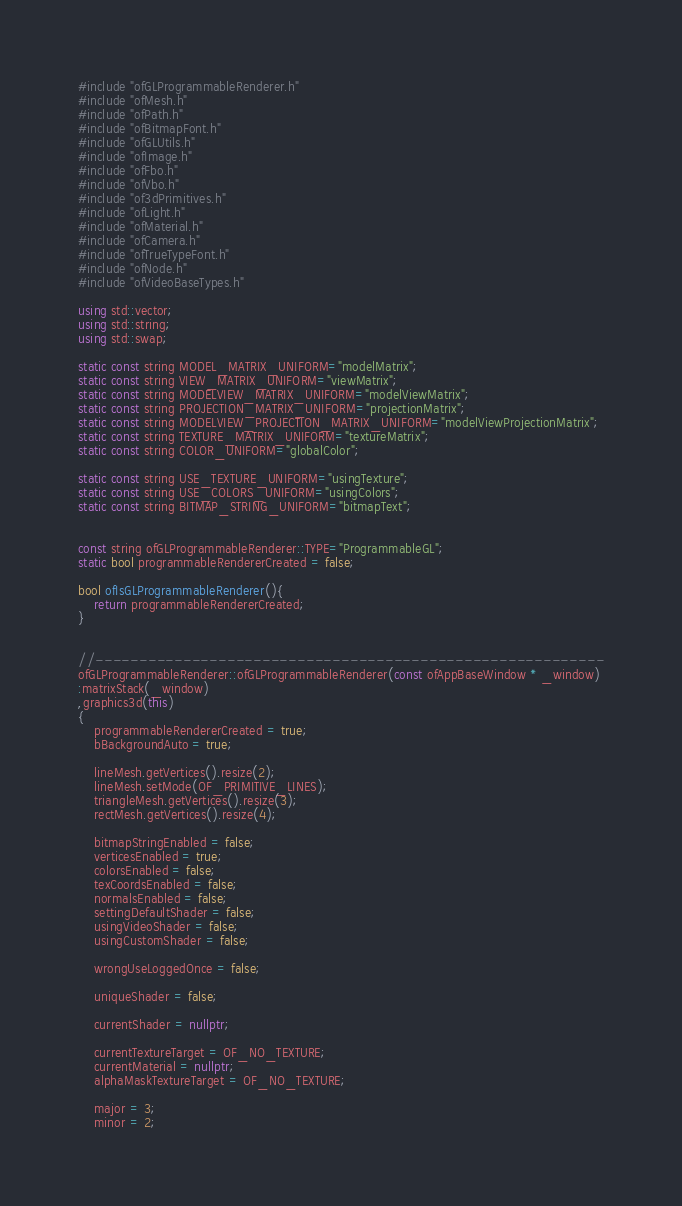<code> <loc_0><loc_0><loc_500><loc_500><_C++_>#include "ofGLProgrammableRenderer.h"
#include "ofMesh.h"
#include "ofPath.h"
#include "ofBitmapFont.h"
#include "ofGLUtils.h"
#include "ofImage.h"
#include "ofFbo.h"
#include "ofVbo.h"
#include "of3dPrimitives.h"
#include "ofLight.h"
#include "ofMaterial.h"
#include "ofCamera.h"
#include "ofTrueTypeFont.h"
#include "ofNode.h"
#include "ofVideoBaseTypes.h"

using std::vector;
using std::string;
using std::swap;

static const string MODEL_MATRIX_UNIFORM="modelMatrix";
static const string VIEW_MATRIX_UNIFORM="viewMatrix";
static const string MODELVIEW_MATRIX_UNIFORM="modelViewMatrix";
static const string PROJECTION_MATRIX_UNIFORM="projectionMatrix";
static const string MODELVIEW_PROJECTION_MATRIX_UNIFORM="modelViewProjectionMatrix";
static const string TEXTURE_MATRIX_UNIFORM="textureMatrix";
static const string COLOR_UNIFORM="globalColor";

static const string USE_TEXTURE_UNIFORM="usingTexture";
static const string USE_COLORS_UNIFORM="usingColors";
static const string BITMAP_STRING_UNIFORM="bitmapText";


const string ofGLProgrammableRenderer::TYPE="ProgrammableGL";
static bool programmableRendererCreated = false;

bool ofIsGLProgrammableRenderer(){
	return programmableRendererCreated;
}


//----------------------------------------------------------
ofGLProgrammableRenderer::ofGLProgrammableRenderer(const ofAppBaseWindow * _window)
:matrixStack(_window)
,graphics3d(this)
{
	programmableRendererCreated = true;
	bBackgroundAuto = true;

	lineMesh.getVertices().resize(2);
	lineMesh.setMode(OF_PRIMITIVE_LINES);
	triangleMesh.getVertices().resize(3);
	rectMesh.getVertices().resize(4);

	bitmapStringEnabled = false;
    verticesEnabled = true;
    colorsEnabled = false;
    texCoordsEnabled = false;
    normalsEnabled = false;
	settingDefaultShader = false;
	usingVideoShader = false;
	usingCustomShader = false;

	wrongUseLoggedOnce = false;

	uniqueShader = false;

	currentShader = nullptr;

	currentTextureTarget = OF_NO_TEXTURE;
	currentMaterial = nullptr;
	alphaMaskTextureTarget = OF_NO_TEXTURE;

	major = 3;
	minor = 2;</code> 